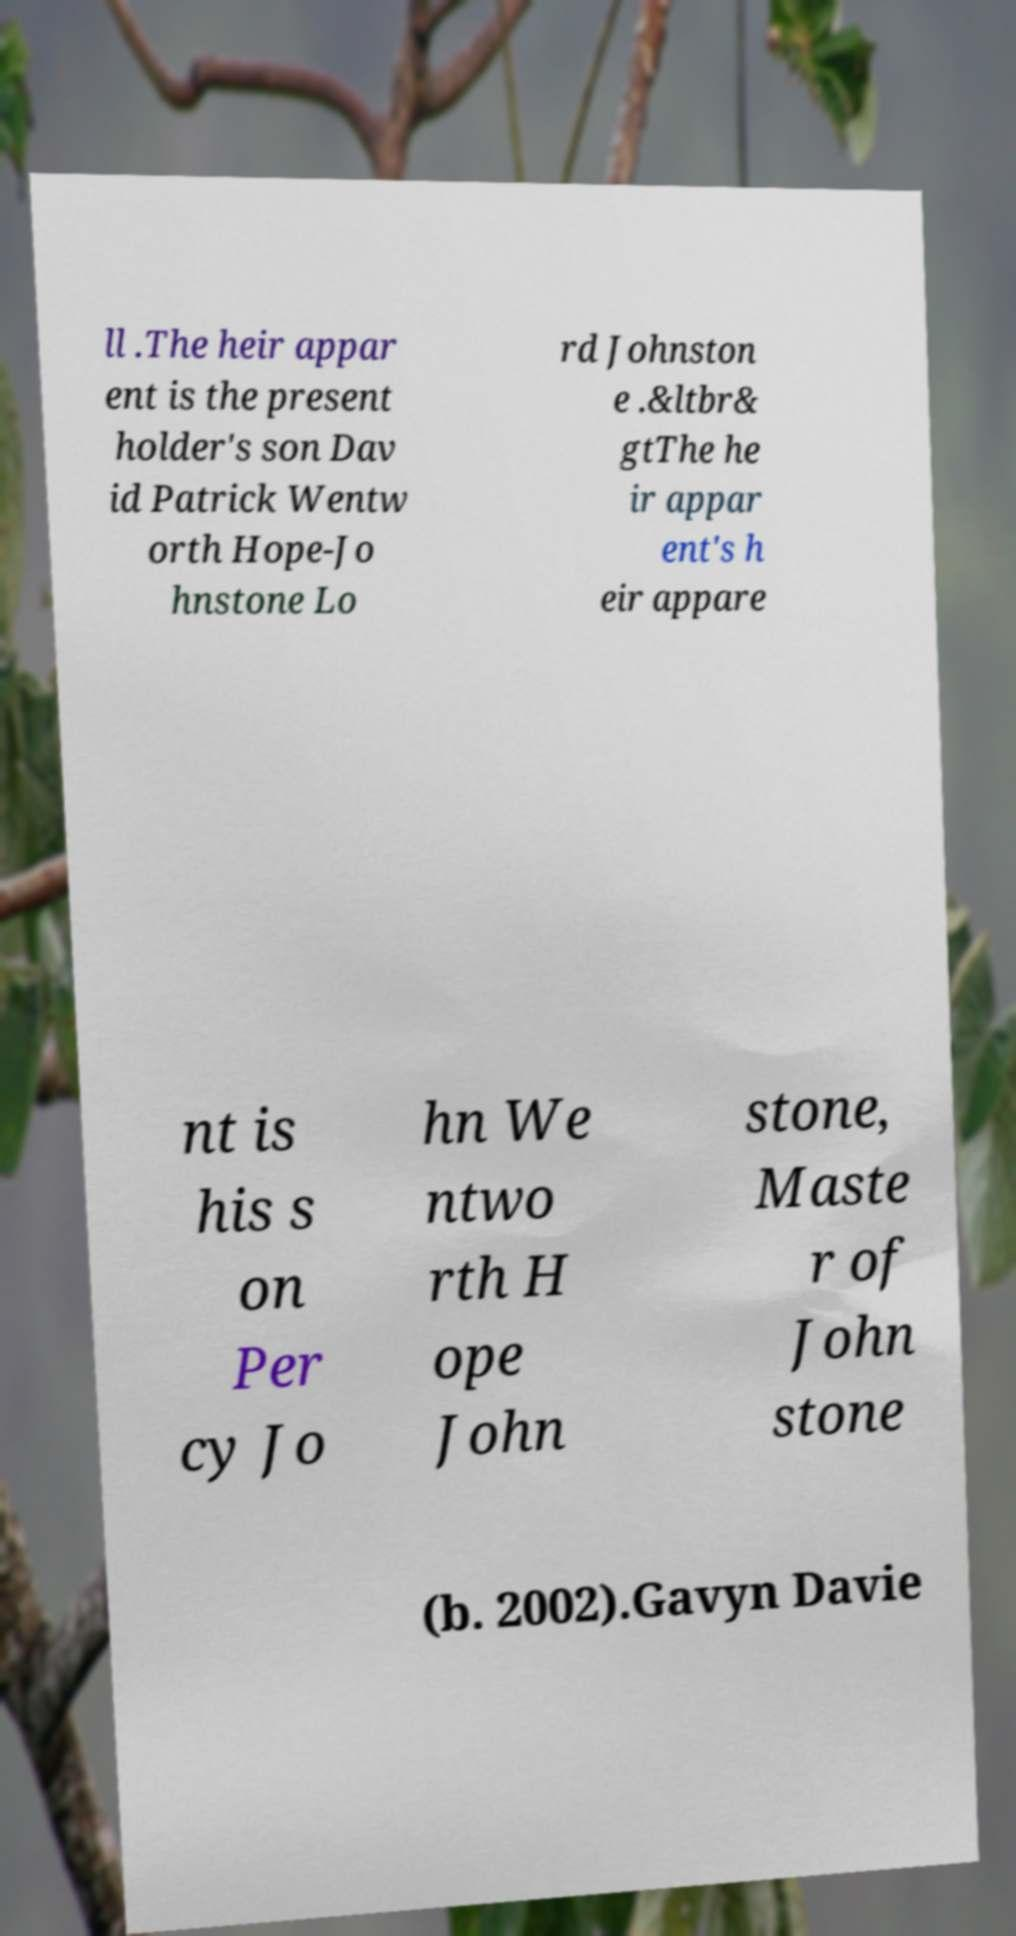Please read and relay the text visible in this image. What does it say? ll .The heir appar ent is the present holder's son Dav id Patrick Wentw orth Hope-Jo hnstone Lo rd Johnston e .&ltbr& gtThe he ir appar ent's h eir appare nt is his s on Per cy Jo hn We ntwo rth H ope John stone, Maste r of John stone (b. 2002).Gavyn Davie 